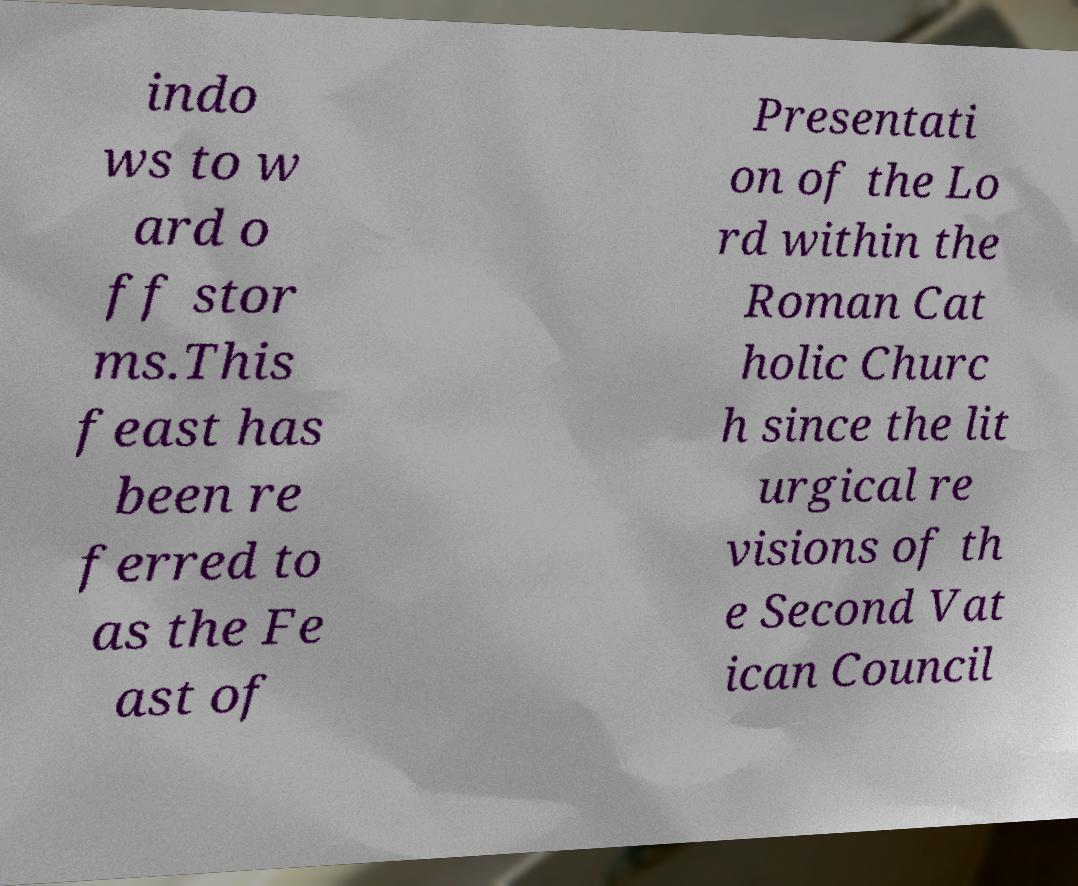Could you extract and type out the text from this image? indo ws to w ard o ff stor ms.This feast has been re ferred to as the Fe ast of Presentati on of the Lo rd within the Roman Cat holic Churc h since the lit urgical re visions of th e Second Vat ican Council 